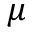<formula> <loc_0><loc_0><loc_500><loc_500>\mu</formula> 